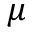<formula> <loc_0><loc_0><loc_500><loc_500>\mu</formula> 